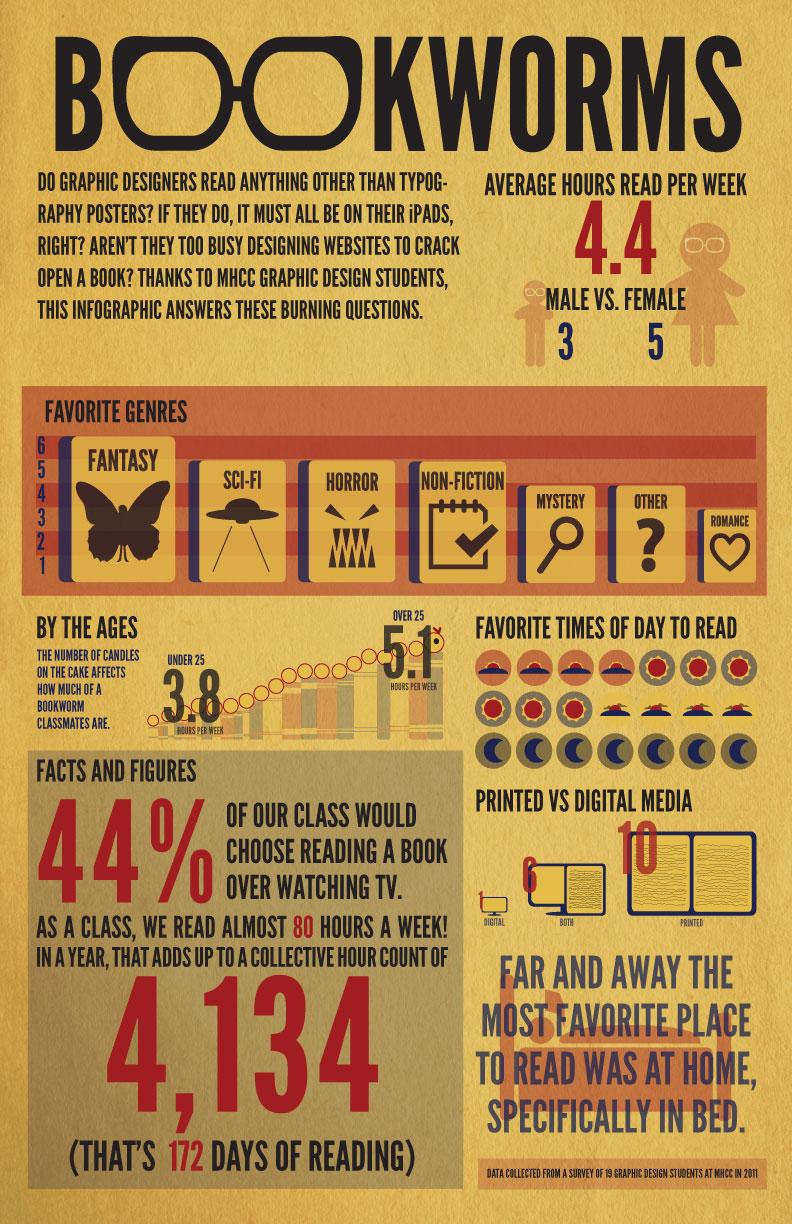List a handful of essential elements in this visual. According to the survey of graphic designer students at MHCC in 2011, a significant number of students preferred e-reading. According to a survey of graphic designer students at MHCC in 2011, 6 out of the students like both digital and printed book reading. According to a survey conducted in 2011 among graphic design students at MHCC, fantasy was the most popular genre of books. According to a survey conducted at MHCC in 2011, male students spent an average of 4.4 hours per week reading. According to a survey conducted in 2011, female students at MHCC spend an average of 4.4 hours per week reading. 